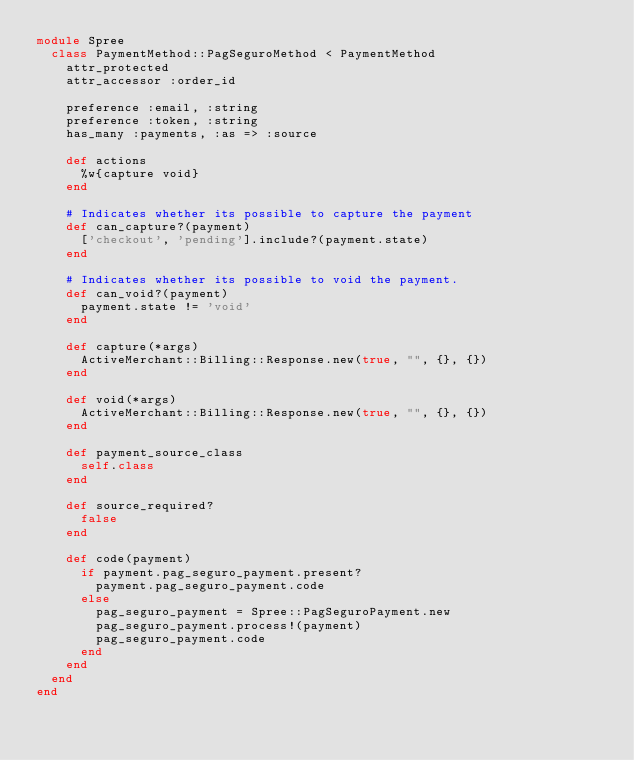<code> <loc_0><loc_0><loc_500><loc_500><_Ruby_>module Spree
  class PaymentMethod::PagSeguroMethod < PaymentMethod
    attr_protected
    attr_accessor :order_id
    
    preference :email, :string
    preference :token, :string
    has_many :payments, :as => :source
    
    def actions
      %w{capture void}
    end

    # Indicates whether its possible to capture the payment
    def can_capture?(payment)
      ['checkout', 'pending'].include?(payment.state)
    end

    # Indicates whether its possible to void the payment.
    def can_void?(payment)
      payment.state != 'void'
    end

    def capture(*args)
      ActiveMerchant::Billing::Response.new(true, "", {}, {})
    end

    def void(*args)
      ActiveMerchant::Billing::Response.new(true, "", {}, {})
    end
    
    def payment_source_class
      self.class
    end

    def source_required?
      false
    end
    
    def code(payment)
      if payment.pag_seguro_payment.present?
        payment.pag_seguro_payment.code
      else
        pag_seguro_payment = Spree::PagSeguroPayment.new
        pag_seguro_payment.process!(payment)
        pag_seguro_payment.code
      end
    end
  end
end
</code> 